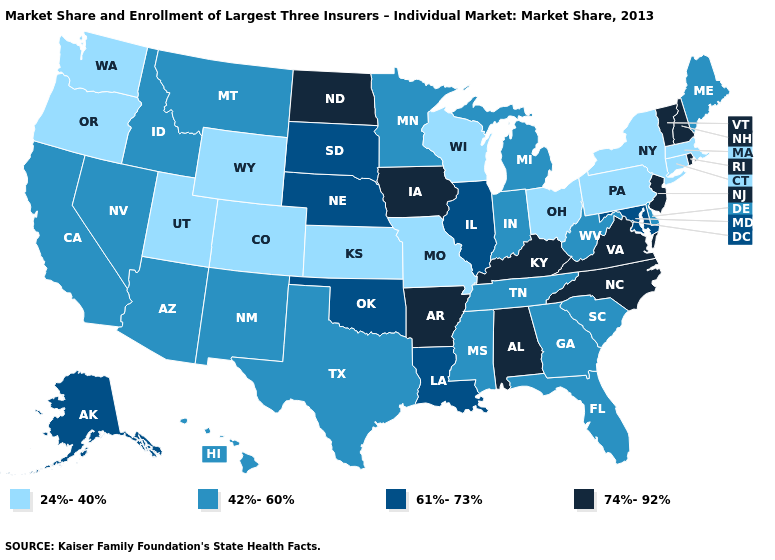Does South Carolina have the highest value in the South?
Short answer required. No. Name the states that have a value in the range 61%-73%?
Be succinct. Alaska, Illinois, Louisiana, Maryland, Nebraska, Oklahoma, South Dakota. Does the first symbol in the legend represent the smallest category?
Quick response, please. Yes. What is the value of New Mexico?
Keep it brief. 42%-60%. Does the map have missing data?
Quick response, please. No. What is the lowest value in the West?
Give a very brief answer. 24%-40%. Name the states that have a value in the range 24%-40%?
Quick response, please. Colorado, Connecticut, Kansas, Massachusetts, Missouri, New York, Ohio, Oregon, Pennsylvania, Utah, Washington, Wisconsin, Wyoming. What is the lowest value in the USA?
Write a very short answer. 24%-40%. Does South Dakota have the highest value in the MidWest?
Answer briefly. No. Name the states that have a value in the range 61%-73%?
Answer briefly. Alaska, Illinois, Louisiana, Maryland, Nebraska, Oklahoma, South Dakota. Name the states that have a value in the range 61%-73%?
Concise answer only. Alaska, Illinois, Louisiana, Maryland, Nebraska, Oklahoma, South Dakota. What is the value of Iowa?
Quick response, please. 74%-92%. What is the value of Ohio?
Keep it brief. 24%-40%. Does Washington have the lowest value in the West?
Short answer required. Yes. 